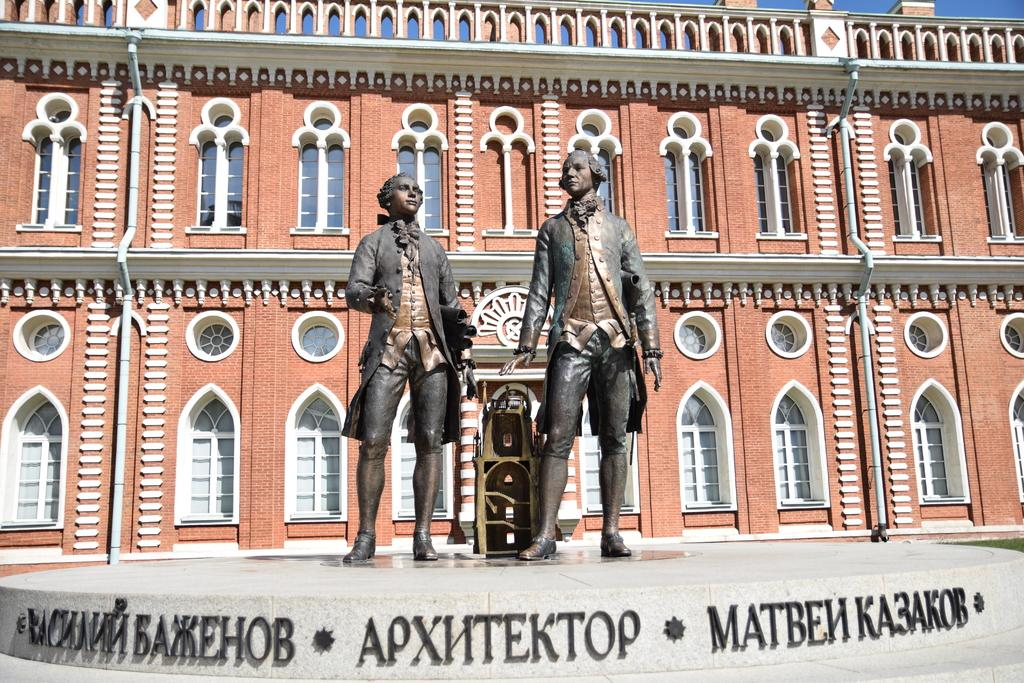How many statues are present in the image? There are two statues in the image. What is the location of the statues in relation to the building? The statues are in front of a building. What type of pickle is being served by the porter in the image? There is no pickle or porter present in the image; it only features two statues in front of a building. 